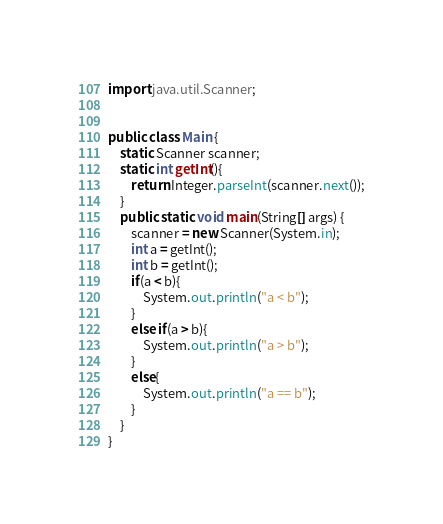<code> <loc_0><loc_0><loc_500><loc_500><_Java_>import java.util.Scanner;


public class Main {
    static Scanner scanner;
    static int getInt(){
        return Integer.parseInt(scanner.next());
    }
    public static void main(String[] args) {
        scanner = new Scanner(System.in);
        int a = getInt();
        int b = getInt();
        if(a < b){
            System.out.println("a < b");
        }
        else if(a > b){
            System.out.println("a > b");
        }
        else{
            System.out.println("a == b");
        }
    }
}

</code> 